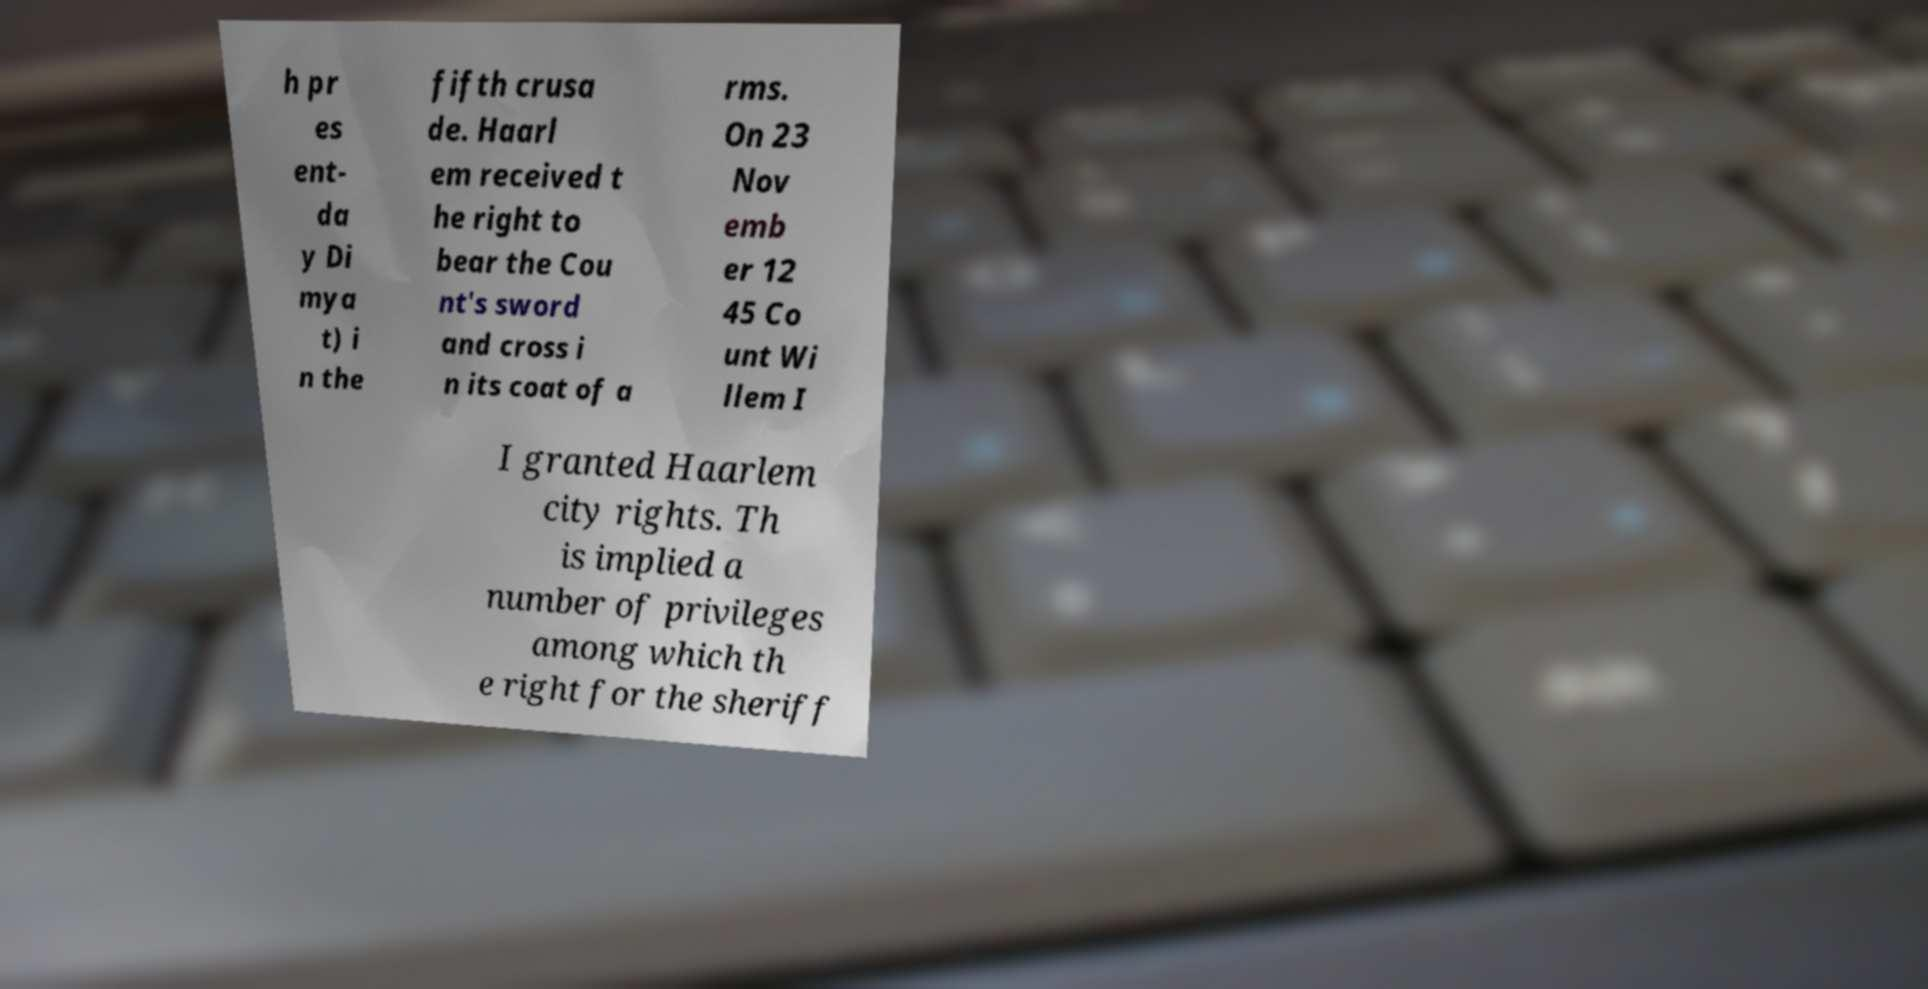There's text embedded in this image that I need extracted. Can you transcribe it verbatim? h pr es ent- da y Di mya t) i n the fifth crusa de. Haarl em received t he right to bear the Cou nt's sword and cross i n its coat of a rms. On 23 Nov emb er 12 45 Co unt Wi llem I I granted Haarlem city rights. Th is implied a number of privileges among which th e right for the sheriff 